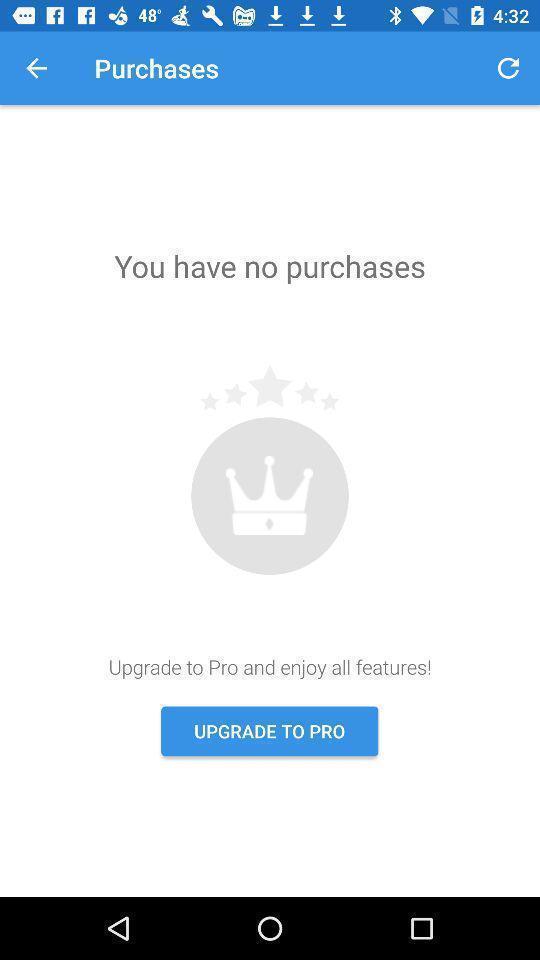Describe the key features of this screenshot. Shopping app with upgrade option. 